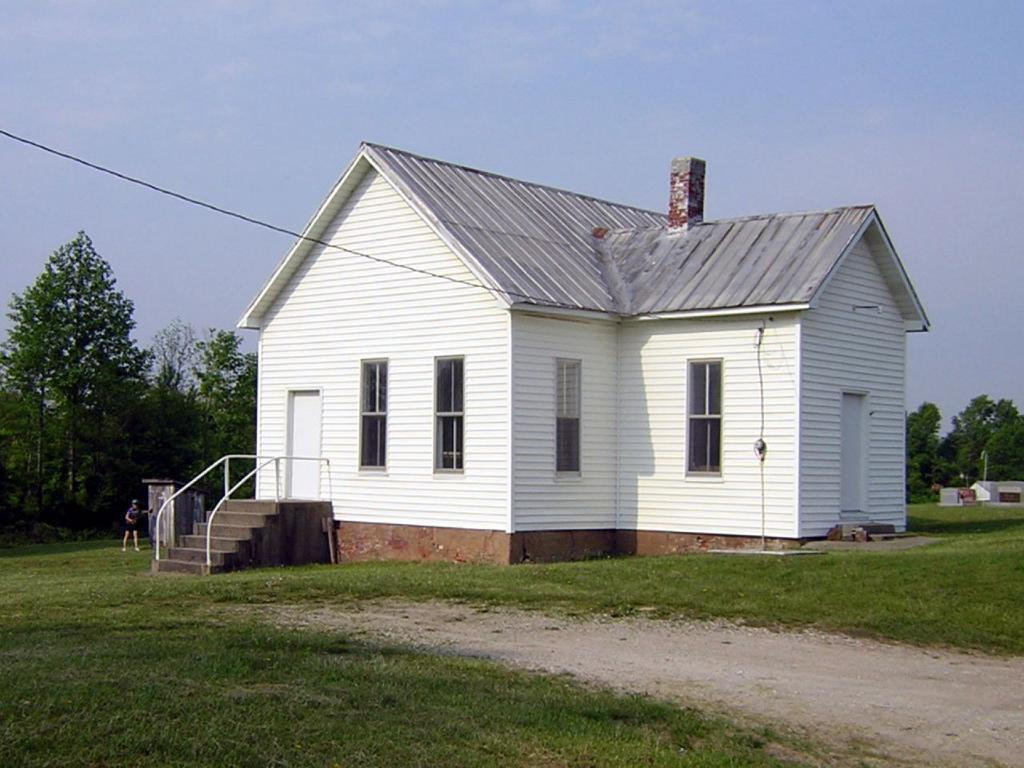What type of structure is located in the middle of the grassland? There is a house in the middle of the grassland. What can be seen behind the house? Trees are present behind the house. Can you describe the person in the image? There appears to be a person standing on the left side of the image. What is visible above the house and the person? The sky is visible above the house and the person. Where are the tomatoes growing in the image? There are no tomatoes present in the image. What type of servant is attending to the person in the image? There is no servant present in the image; only a person is visible. 